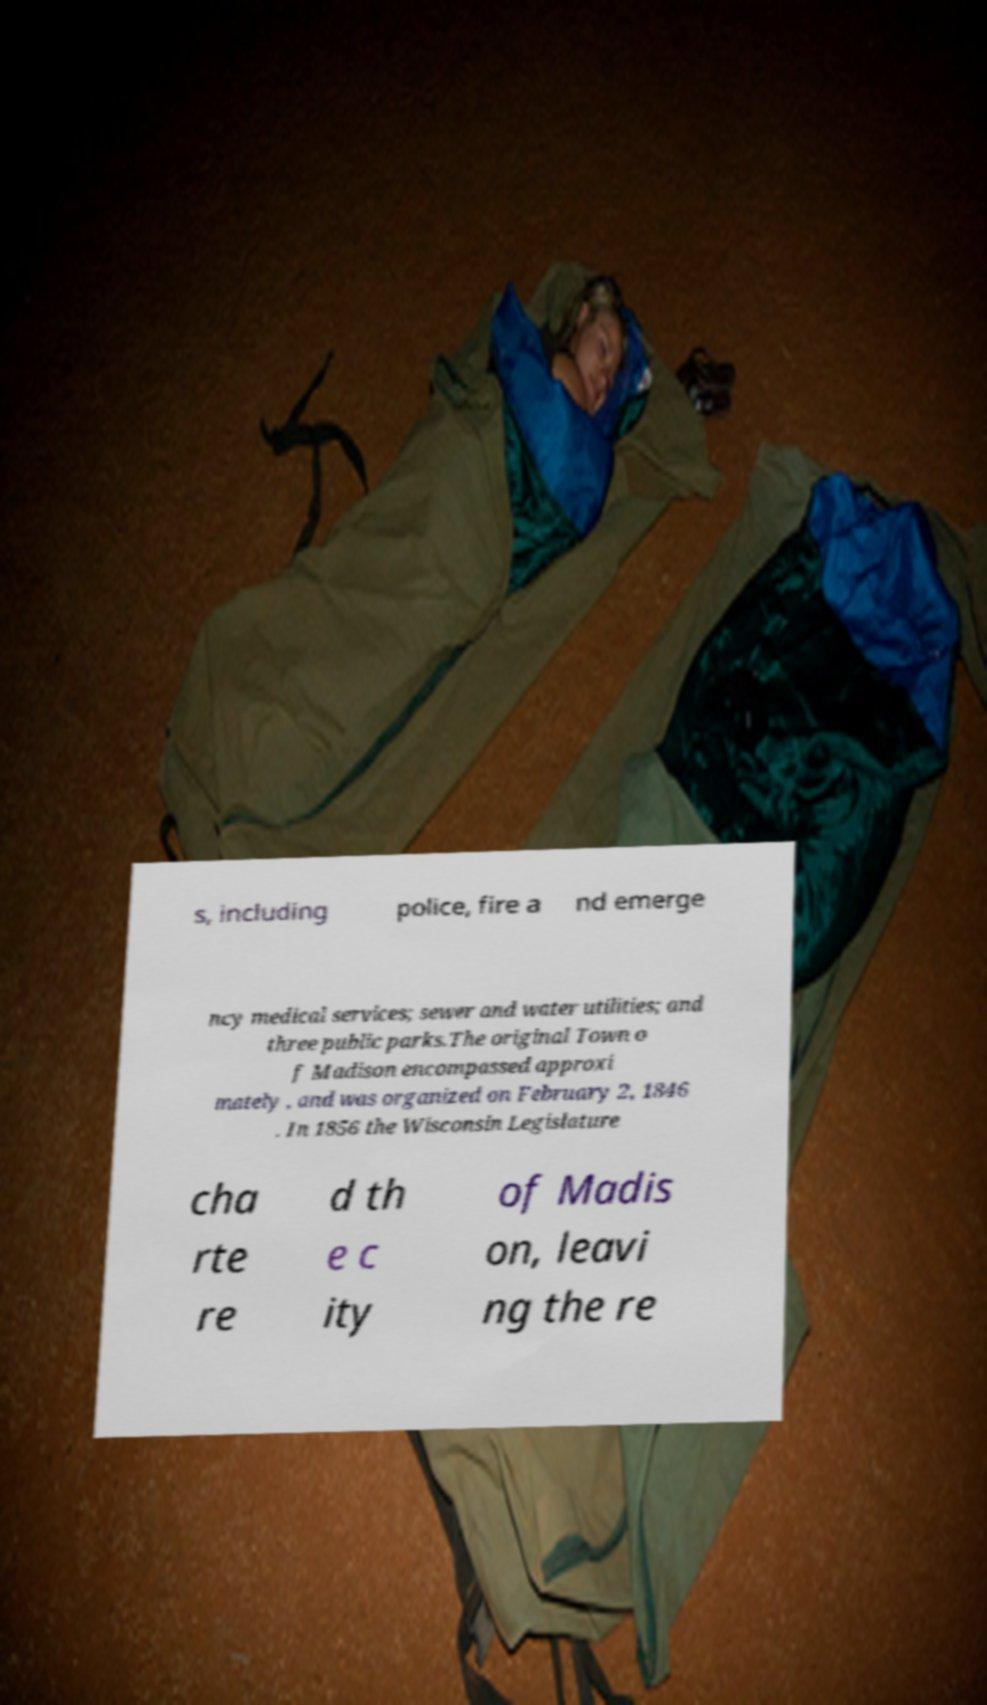There's text embedded in this image that I need extracted. Can you transcribe it verbatim? s, including police, fire a nd emerge ncy medical services; sewer and water utilities; and three public parks.The original Town o f Madison encompassed approxi mately , and was organized on February 2, 1846 . In 1856 the Wisconsin Legislature cha rte re d th e c ity of Madis on, leavi ng the re 